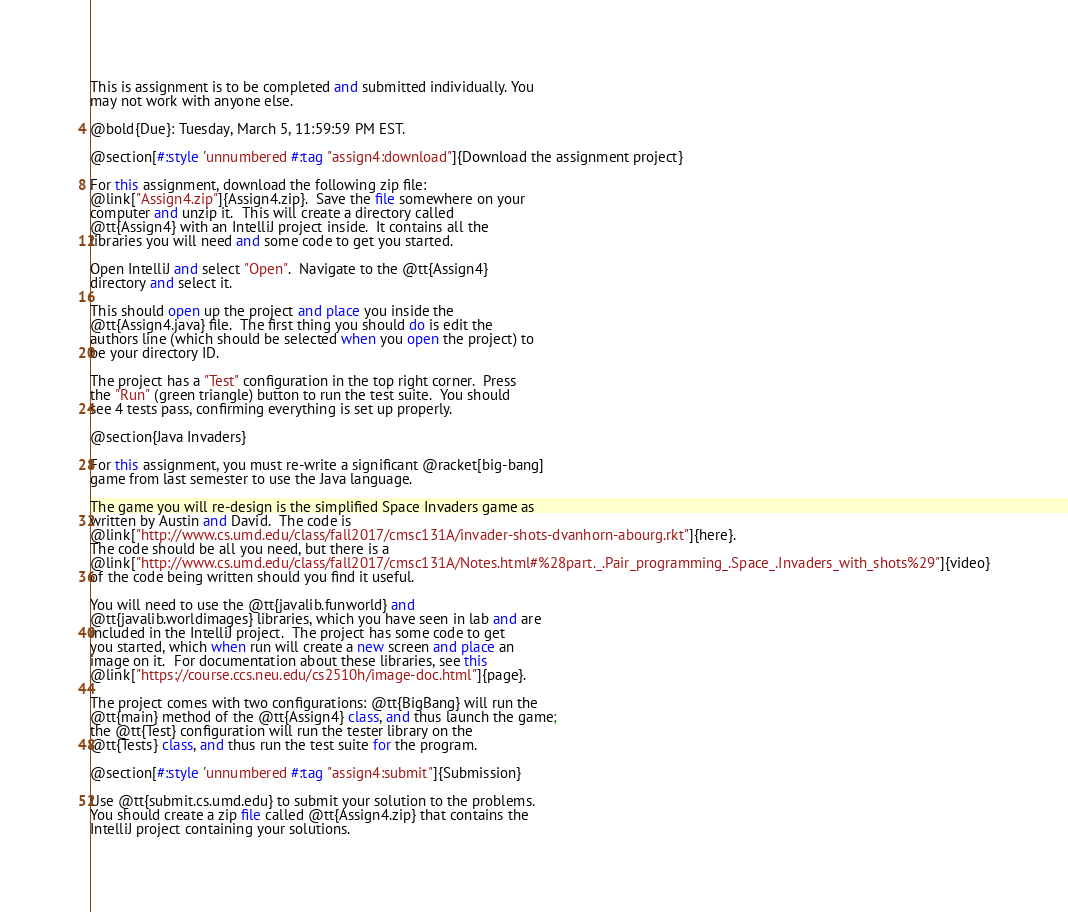Convert code to text. <code><loc_0><loc_0><loc_500><loc_500><_Racket_>
This is assignment is to be completed and submitted individually. You
may not work with anyone else.

@bold{Due}: Tuesday, March 5, 11:59:59 PM EST.

@section[#:style 'unnumbered #:tag "assign4:download"]{Download the assignment project}

For this assignment, download the following zip file:
@link["Assign4.zip"]{Assign4.zip}.  Save the file somewhere on your
computer and unzip it.  This will create a directory called
@tt{Assign4} with an IntelliJ project inside.  It contains all the
libraries you will need and some code to get you started.

Open IntelliJ and select "Open".  Navigate to the @tt{Assign4}
directory and select it.

This should open up the project and place you inside the
@tt{Assign4.java} file.  The first thing you should do is edit the
authors line (which should be selected when you open the project) to
be your directory ID.

The project has a "Test" configuration in the top right corner.  Press
the "Run" (green triangle) button to run the test suite.  You should
see 4 tests pass, confirming everything is set up properly.

@section{Java Invaders}

For this assignment, you must re-write a significant @racket[big-bang]
game from last semester to use the Java language. 

The game you will re-design is the simplified Space Invaders game as
written by Austin and David.  The code is
@link["http://www.cs.umd.edu/class/fall2017/cmsc131A/invader-shots-dvanhorn-abourg.rkt"]{here}.
The code should be all you need, but there is a
@link["http://www.cs.umd.edu/class/fall2017/cmsc131A/Notes.html#%28part._.Pair_programming_.Space_.Invaders_with_shots%29"]{video}
of the code being written should you find it useful.

You will need to use the @tt{javalib.funworld} and
@tt{javalib.worldimages} libraries, which you have seen in lab and are
included in the IntelliJ project.  The project has some code to get
you started, which when run will create a new screen and place an
image on it.  For documentation about these libraries, see this
@link["https://course.ccs.neu.edu/cs2510h/image-doc.html"]{page}.

The project comes with two configurations: @tt{BigBang} will run the
@tt{main} method of the @tt{Assign4} class, and thus launch the game;
the @tt{Test} configuration will run the tester library on the
@tt{Tests} class, and thus run the test suite for the program.

@section[#:style 'unnumbered #:tag "assign4:submit"]{Submission}

Use @tt{submit.cs.umd.edu} to submit your solution to the problems.
You should create a zip file called @tt{Assign4.zip} that contains the
IntelliJ project containing your solutions.
</code> 